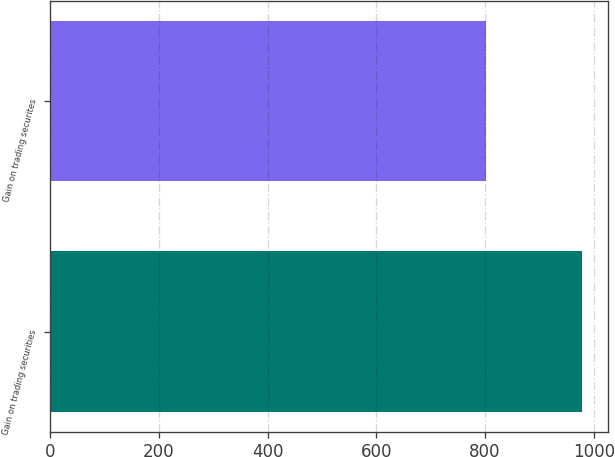Convert chart to OTSL. <chart><loc_0><loc_0><loc_500><loc_500><bar_chart><fcel>Gain on trading securities<fcel>Gain on trading securites<nl><fcel>978<fcel>801<nl></chart> 